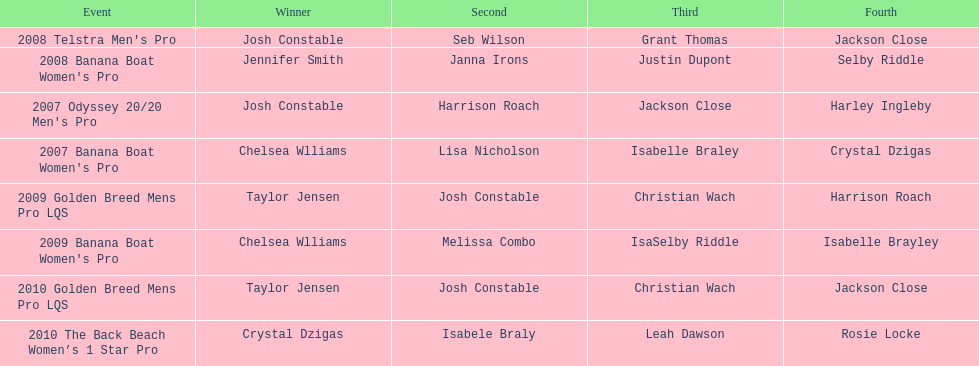In what event did chelsea williams win her first title? 2007 Banana Boat Women's Pro. 